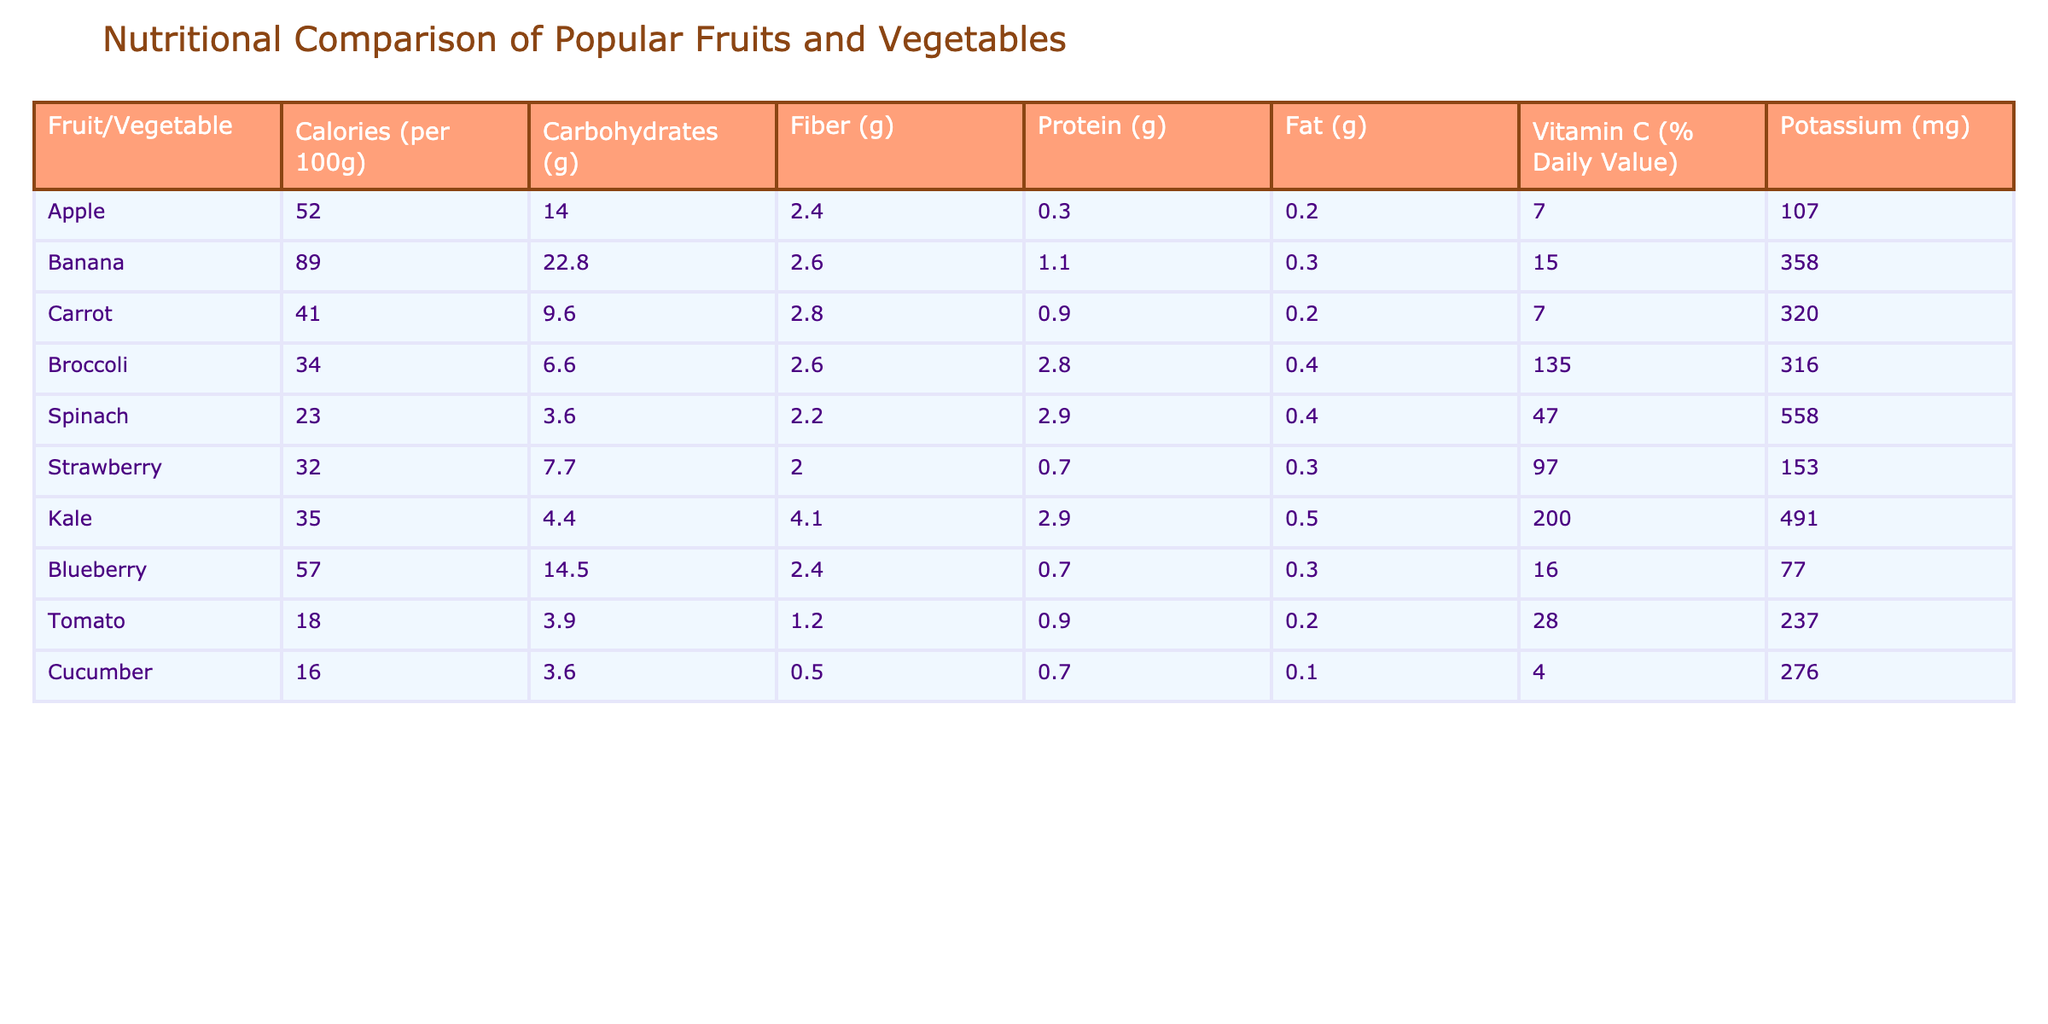What is the calorie content of a banana? The table states that bananas contain 89 calories per 100g.
Answer: 89 Which fruit has the highest amount of Vitamin C? By looking at the Vitamin C values (% Daily Value) for each fruit, kale has the highest at 200%.
Answer: Kale What is the total carbohydrate content of carrot and cucumber combined? The carbohydrate content for carrot is 9.6g and for cucumber, it is 3.6g. Adding these gives: 9.6 + 3.6 = 13.2g.
Answer: 13.2g Does spinach have more fiber than broccoli? Spinach has 2.2g of fiber while broccoli has 2.6g. Since 2.2g is less than 2.6g, the statement is false.
Answer: No What is the average potassium content of the fruits listed? The potassium values are: 358 (banana), 107 (apple), 153 (strawberry), 77 (blueberry), 237 (tomato), 276 (cucumber), adding these gives: 1008, and with 6 data points, the average is 1008/6 = 168.
Answer: 168 Which vegetable has the least calories? By checking the calorie content for each food, cucumber has the lowest at 16 calories per 100g.
Answer: Cucumber Is the protein content of tomato higher than that of carrot? Tomato contains 0.9g of protein, while carrot has 0.9g as well. Since they are equal, it is not higher.
Answer: No What is the difference in fiber content between kale and spinach? Kale has 4.1g of fiber, and spinach has 2.2g. The difference is calculated as 4.1 - 2.2 = 1.9g.
Answer: 1.9g Which fruit has the highest potassium content? The potassium values indicate that banana has the highest at 358mg.
Answer: Banana 